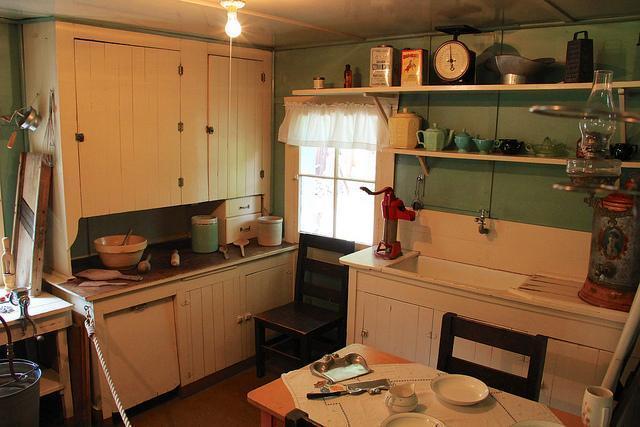How many chairs are there?
Give a very brief answer. 2. How many stove does this kitchen have?
Give a very brief answer. 0. How many chairs can be seen?
Give a very brief answer. 2. How many giraffes are adults?
Give a very brief answer. 0. 